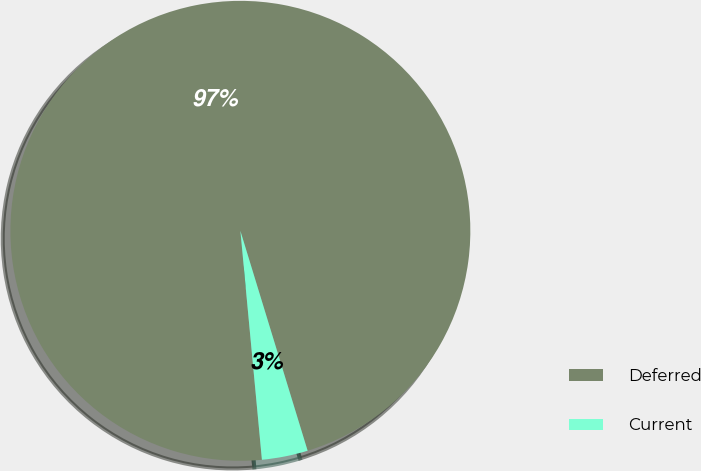Convert chart. <chart><loc_0><loc_0><loc_500><loc_500><pie_chart><fcel>Deferred<fcel>Current<nl><fcel>96.77%<fcel>3.23%<nl></chart> 